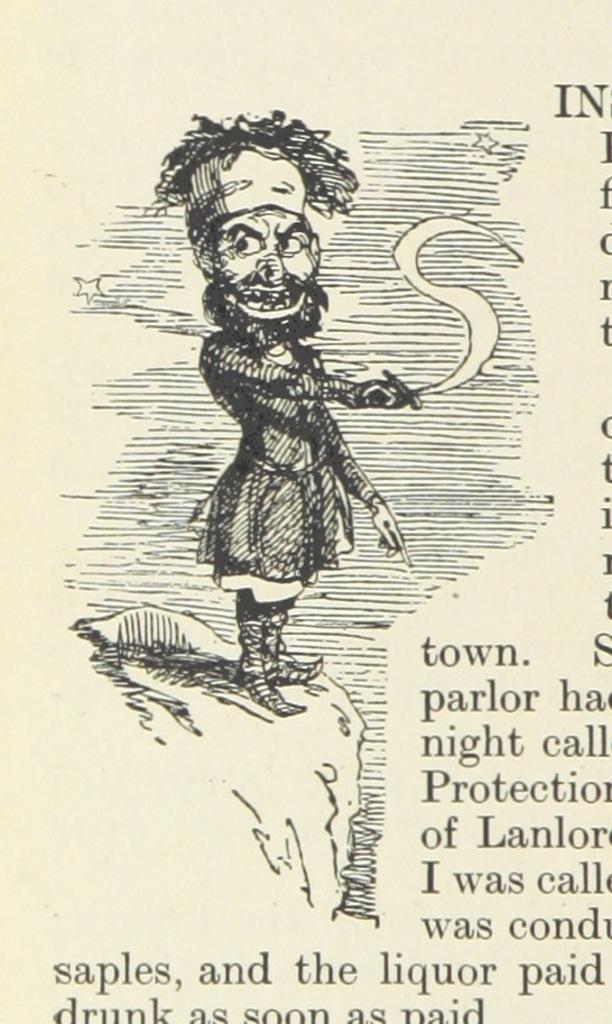What is the main subject of the image? The image appears to be a page. What can be seen on the page? There is an animated image on the page. Is there any text present on the page? Yes, there is some text beside the animated image. Where is the family located in the image? There is no family present in the image; it only features an animated image and some text. What type of town is depicted in the image? There is no town depicted in the image; it only features an animated image and some text. 